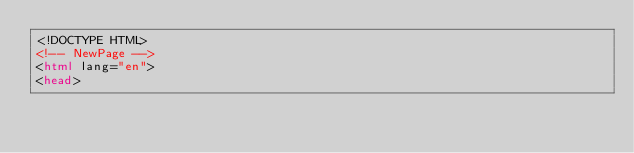<code> <loc_0><loc_0><loc_500><loc_500><_HTML_><!DOCTYPE HTML>
<!-- NewPage -->
<html lang="en">
<head></code> 